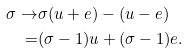<formula> <loc_0><loc_0><loc_500><loc_500>\sigma \rightarrow & \sigma ( u + e ) - ( u - e ) \\ = & ( \sigma - 1 ) u + ( \sigma - 1 ) e .</formula> 